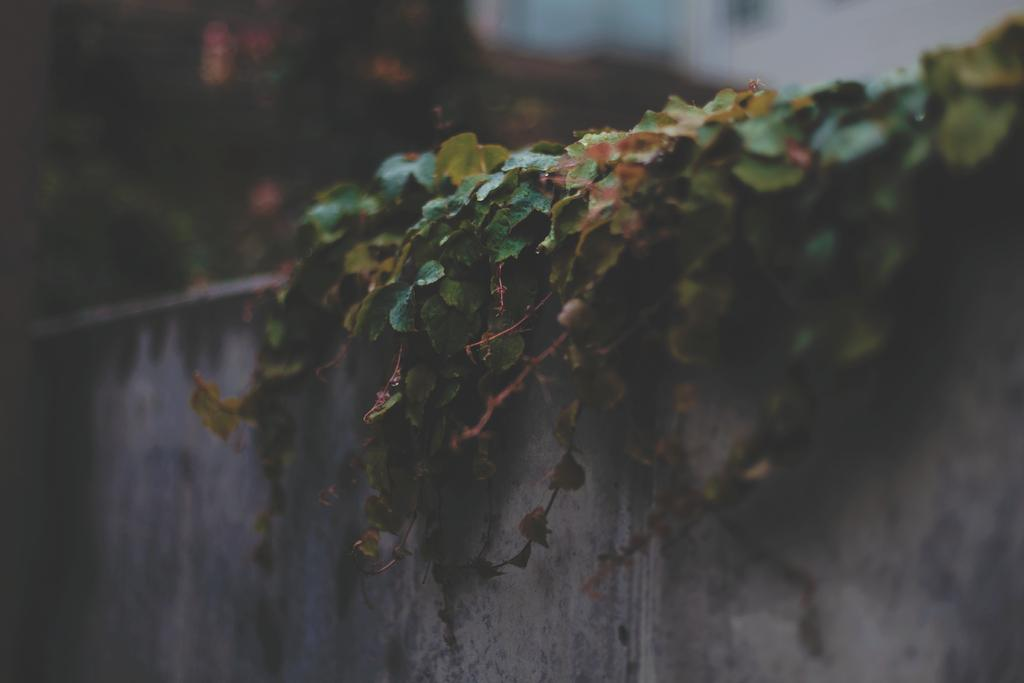What type of plants are growing on the wall in the image? There are creeper plants on the wall in the image. Can you describe the background of the image? The background of the image is blurry. How many dolls are sitting on the cable in the image? There are no dolls or cables present in the image; it only features creeper plants on the wall and a blurry background. 